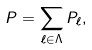<formula> <loc_0><loc_0><loc_500><loc_500>P = \sum _ { \ell \in \Lambda } P _ { \ell } ,</formula> 